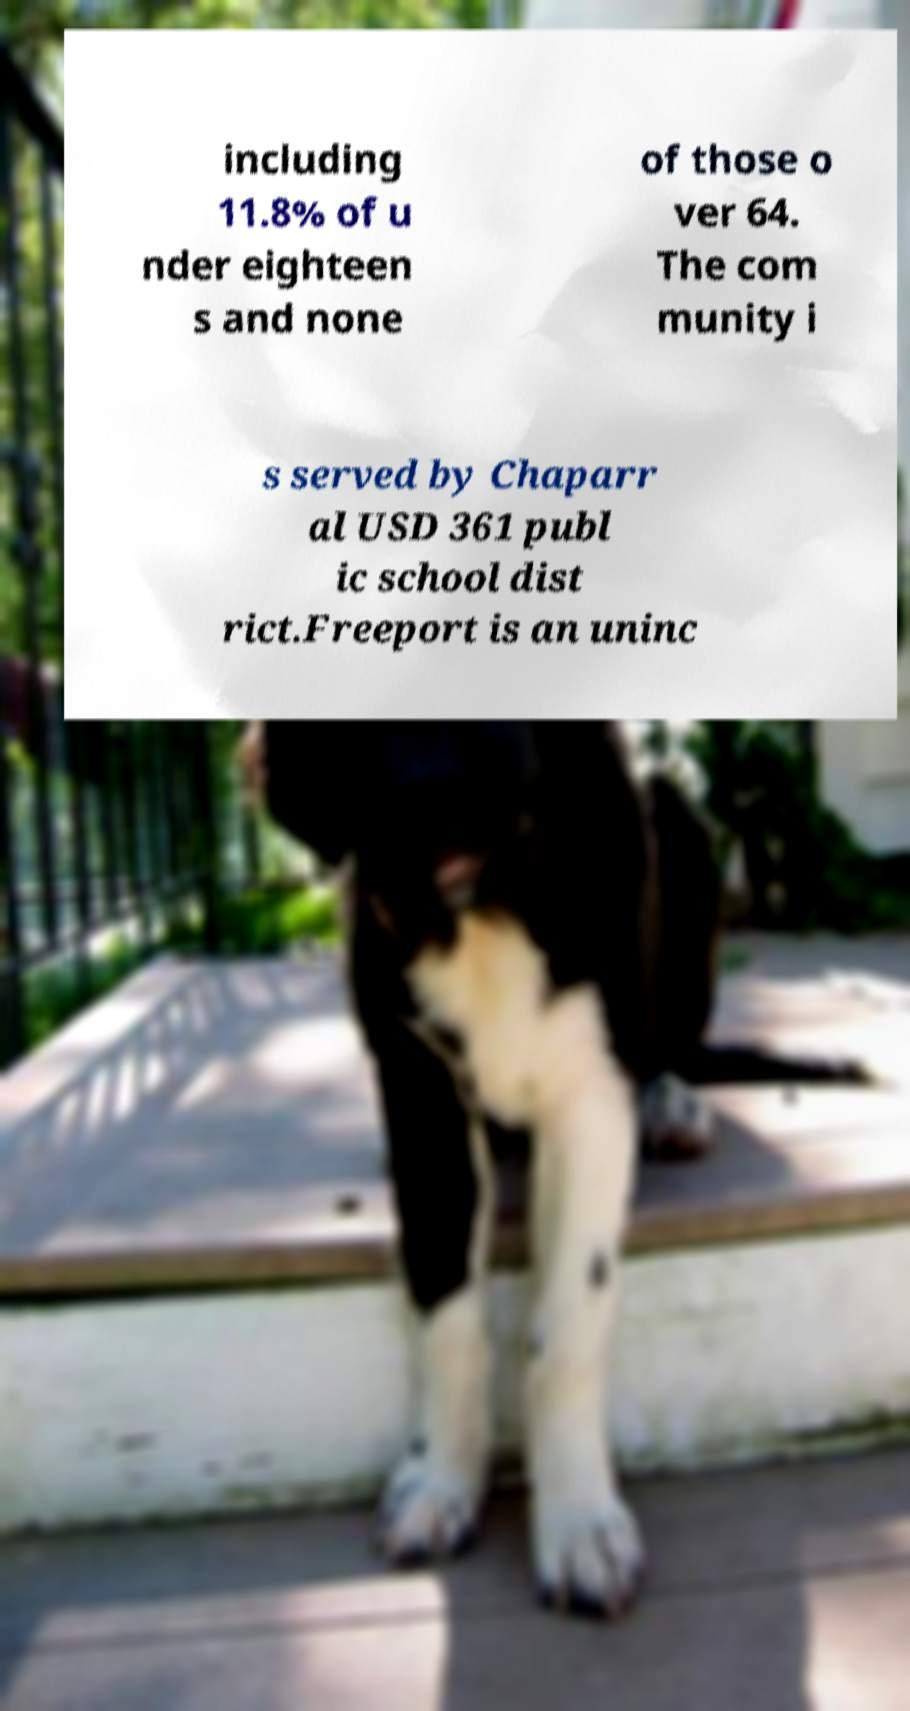Please read and relay the text visible in this image. What does it say? including 11.8% of u nder eighteen s and none of those o ver 64. The com munity i s served by Chaparr al USD 361 publ ic school dist rict.Freeport is an uninc 